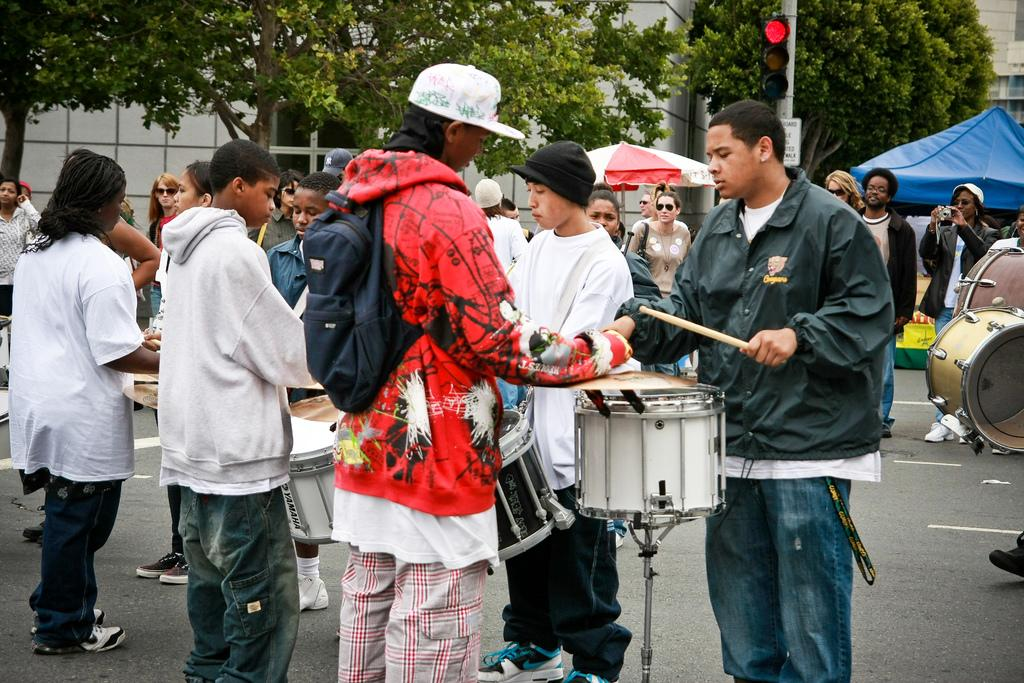How many people are in the image? There is a group of people in the image. Where are the people located in the image? The people are standing on the road. What are the people doing in the image? The people are playing drums. What can be seen in the background of the image? There is a tree and a building in the image. What type of stem can be seen growing from the building in the image? There is no stem growing from the building in the image. What action is the silk performing in the image? There is no silk present in the image. 